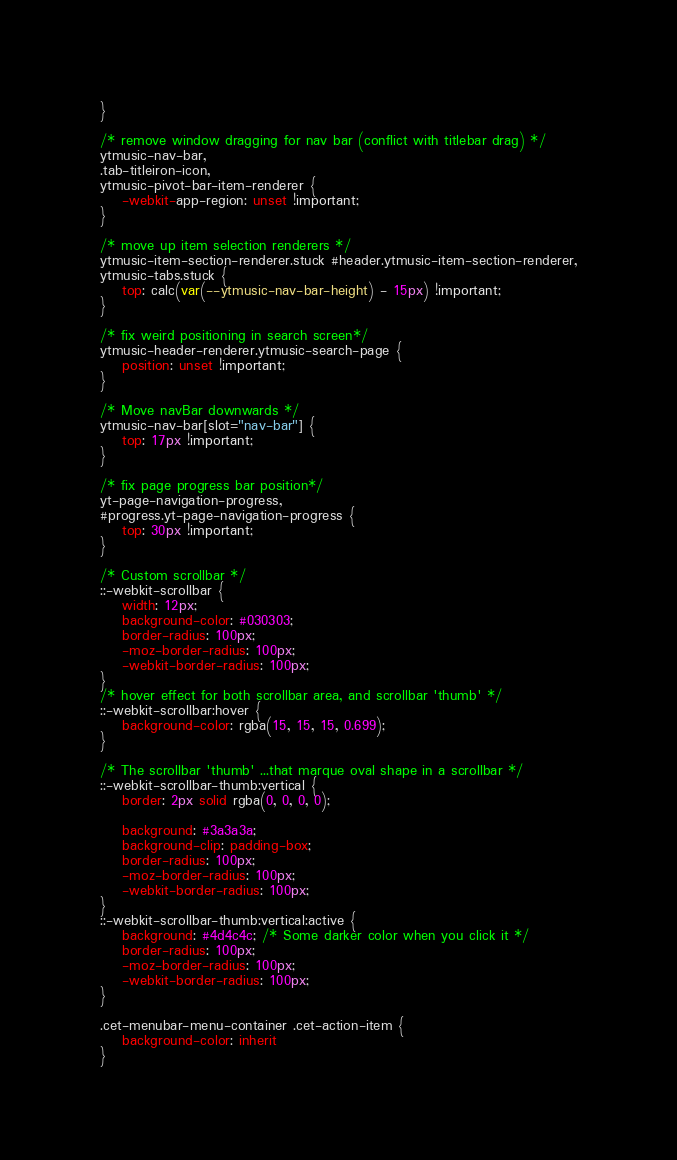<code> <loc_0><loc_0><loc_500><loc_500><_CSS_>}

/* remove window dragging for nav bar (conflict with titlebar drag) */
ytmusic-nav-bar,
.tab-titleiron-icon,
ytmusic-pivot-bar-item-renderer {
	-webkit-app-region: unset !important;
}

/* move up item selection renderers */
ytmusic-item-section-renderer.stuck #header.ytmusic-item-section-renderer,
ytmusic-tabs.stuck {
	top: calc(var(--ytmusic-nav-bar-height) - 15px) !important;
}

/* fix weird positioning in search screen*/
ytmusic-header-renderer.ytmusic-search-page {
	position: unset !important;
}

/* Move navBar downwards */
ytmusic-nav-bar[slot="nav-bar"] {
	top: 17px !important;
}

/* fix page progress bar position*/
yt-page-navigation-progress,
#progress.yt-page-navigation-progress {
	top: 30px !important;
}

/* Custom scrollbar */
::-webkit-scrollbar {
	width: 12px;
	background-color: #030303;
	border-radius: 100px;
	-moz-border-radius: 100px;
	-webkit-border-radius: 100px;
}
/* hover effect for both scrollbar area, and scrollbar 'thumb' */
::-webkit-scrollbar:hover {
	background-color: rgba(15, 15, 15, 0.699);
}

/* The scrollbar 'thumb' ...that marque oval shape in a scrollbar */
::-webkit-scrollbar-thumb:vertical {
	border: 2px solid rgba(0, 0, 0, 0);

	background: #3a3a3a;
	background-clip: padding-box;
	border-radius: 100px;
	-moz-border-radius: 100px;
	-webkit-border-radius: 100px;
}
::-webkit-scrollbar-thumb:vertical:active {
	background: #4d4c4c; /* Some darker color when you click it */
	border-radius: 100px;
	-moz-border-radius: 100px;
	-webkit-border-radius: 100px;
}

.cet-menubar-menu-container .cet-action-item {
	background-color: inherit
}
</code> 